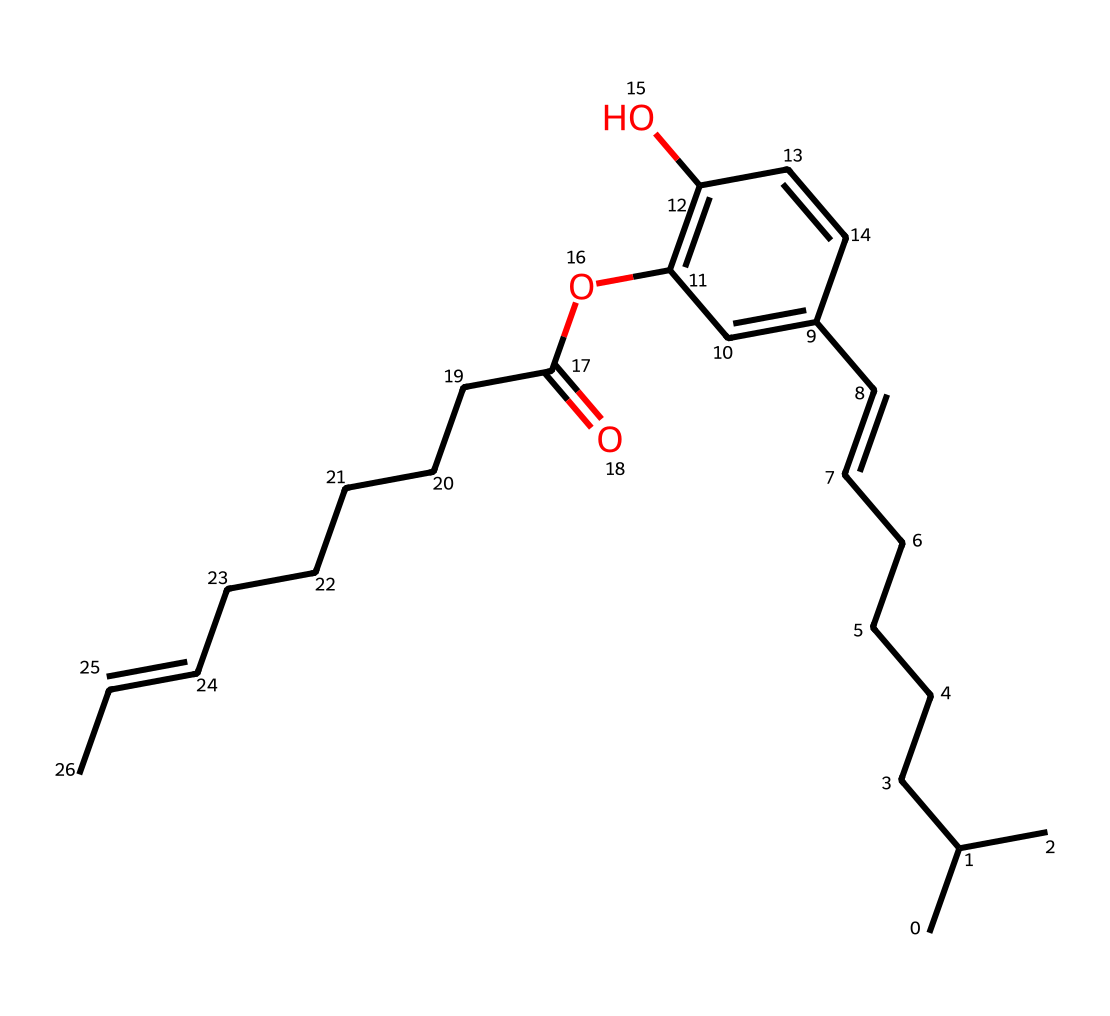What is the molecular formula of capsaicin based on its structure? To determine the molecular formula, count the number of each type of atom in the structure. The structure contains 18 carbon atoms (C), 27 hydrogen atoms (H), and 3 oxygen atoms (O). Therefore, the molecular formula is C18H27O3.
Answer: C18H27O3 How many rings are present in the structure of capsaicin? Analyzing the structure reveals that there is one distinct ring present in the chemical, which is indicated by a cyclic structure denoted in the SMILES.
Answer: 1 What functional groups are present in capsaicin? By examining the structure, we can identify the presence of a phenolic group (due to the hydroxyl group attached to the aromatic ring) and an ester group (from the -O- connected to another carbon chain). Thus, the main functional groups are phenolic and ester.
Answer: phenolic and ester Which carbon chain in capsaicin contributes to its hydrophobic character? The long hydrocarbon chains attached to the aromatic ring provide the bulk of the hydrophobic character in capsaicin. The presence of multiple carbon atoms in a straight-chain format contributes to this property.
Answer: hydrocarbon chains What does the presence of a double bond in the structure indicate about capsaicin? The presence of double bonds within the long carbon chains indicates that capsaicin has unsaturation, which can influence its reactivity and physical properties. This structure can be confirmed by locating the '/C=C/' segments in the SMILES representation.
Answer: unsaturation What type of chemical is capsaicin classified as based on its structure? Capsaicin can be classified as a vanilloid due to the presence of both a phenolic structure and a long carbon chain that contributes to its biological activity. This classification aligns with other compounds that exhibit similar properties and stimulate the same receptors.
Answer: vanilloid 